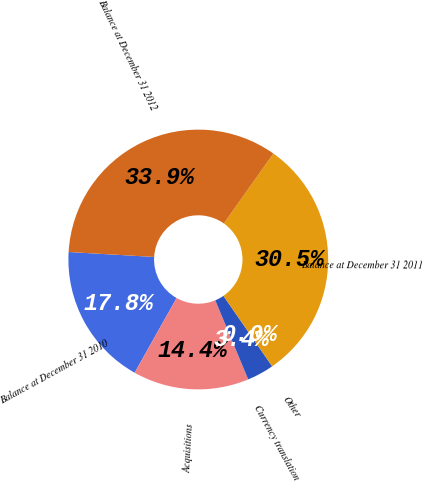<chart> <loc_0><loc_0><loc_500><loc_500><pie_chart><fcel>Balance at December 31 2010<fcel>Acquisitions<fcel>Currency translation<fcel>Other<fcel>Balance at December 31 2011<fcel>Balance at December 31 2012<nl><fcel>17.77%<fcel>14.43%<fcel>3.35%<fcel>0.01%<fcel>30.55%<fcel>33.89%<nl></chart> 